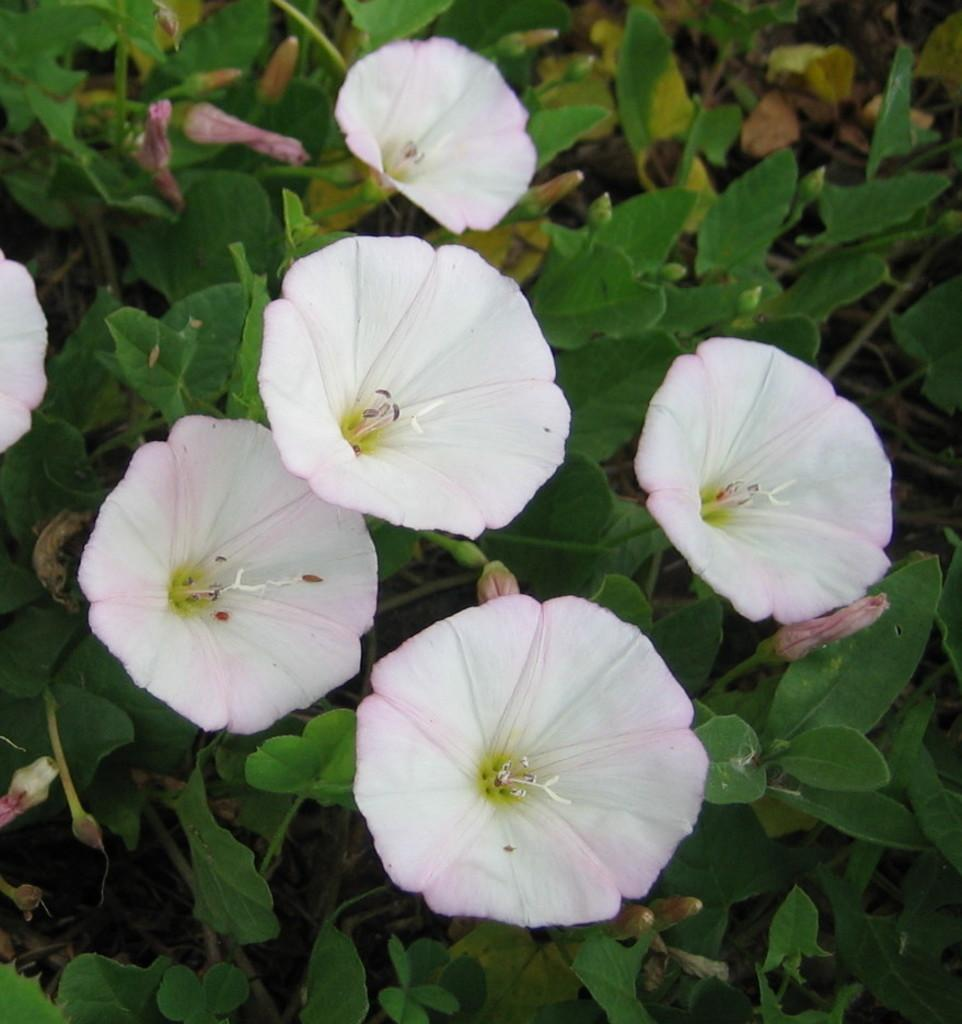What is the main subject of the image? The main subject of the image is a group of plants. What can be observed about the plants in the image? The plants have flowers and buds. What type of power line can be seen running through the library in the image? There is no power line or library present in the image; it features a group of plants with flowers and buds. 